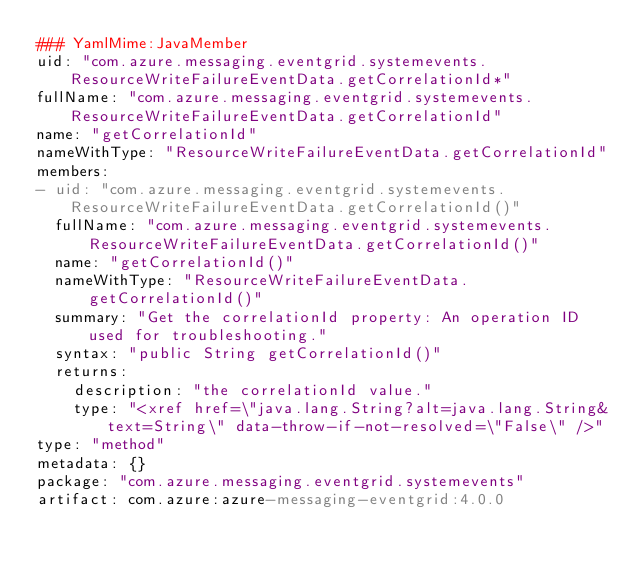Convert code to text. <code><loc_0><loc_0><loc_500><loc_500><_YAML_>### YamlMime:JavaMember
uid: "com.azure.messaging.eventgrid.systemevents.ResourceWriteFailureEventData.getCorrelationId*"
fullName: "com.azure.messaging.eventgrid.systemevents.ResourceWriteFailureEventData.getCorrelationId"
name: "getCorrelationId"
nameWithType: "ResourceWriteFailureEventData.getCorrelationId"
members:
- uid: "com.azure.messaging.eventgrid.systemevents.ResourceWriteFailureEventData.getCorrelationId()"
  fullName: "com.azure.messaging.eventgrid.systemevents.ResourceWriteFailureEventData.getCorrelationId()"
  name: "getCorrelationId()"
  nameWithType: "ResourceWriteFailureEventData.getCorrelationId()"
  summary: "Get the correlationId property: An operation ID used for troubleshooting."
  syntax: "public String getCorrelationId()"
  returns:
    description: "the correlationId value."
    type: "<xref href=\"java.lang.String?alt=java.lang.String&text=String\" data-throw-if-not-resolved=\"False\" />"
type: "method"
metadata: {}
package: "com.azure.messaging.eventgrid.systemevents"
artifact: com.azure:azure-messaging-eventgrid:4.0.0
</code> 